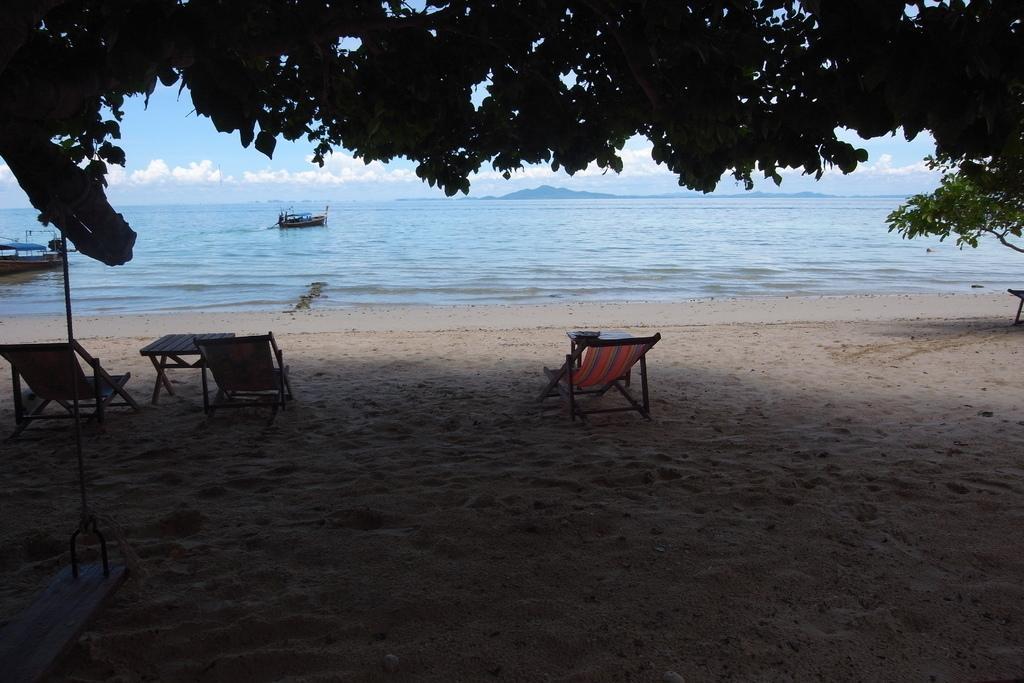Can you describe this image briefly? This is a beach. Here I can see few chairs on the sand. In the background there are two boats on the water and also I can see the sky and clouds. At the top of the image I can see the leaves. 